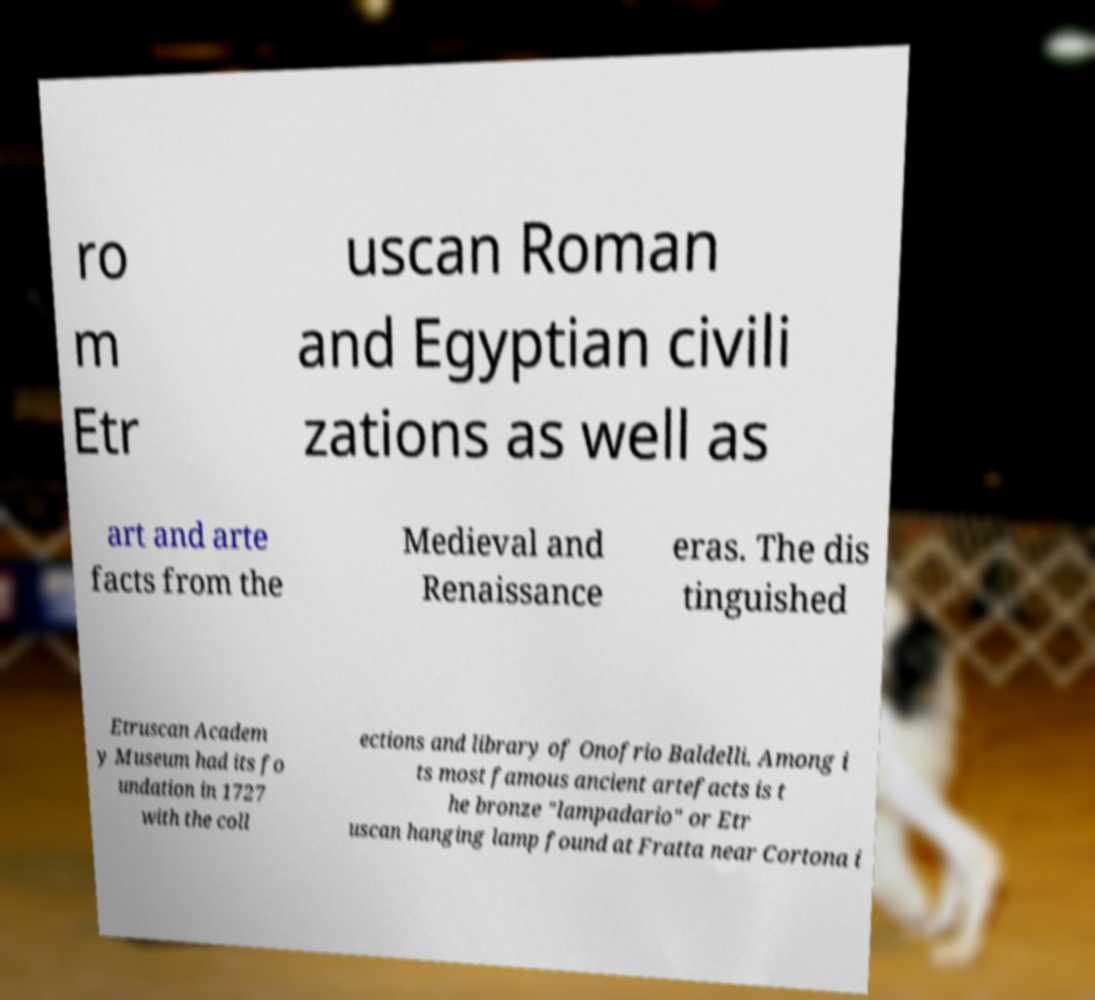For documentation purposes, I need the text within this image transcribed. Could you provide that? ro m Etr uscan Roman and Egyptian civili zations as well as art and arte facts from the Medieval and Renaissance eras. The dis tinguished Etruscan Academ y Museum had its fo undation in 1727 with the coll ections and library of Onofrio Baldelli. Among i ts most famous ancient artefacts is t he bronze "lampadario" or Etr uscan hanging lamp found at Fratta near Cortona i 